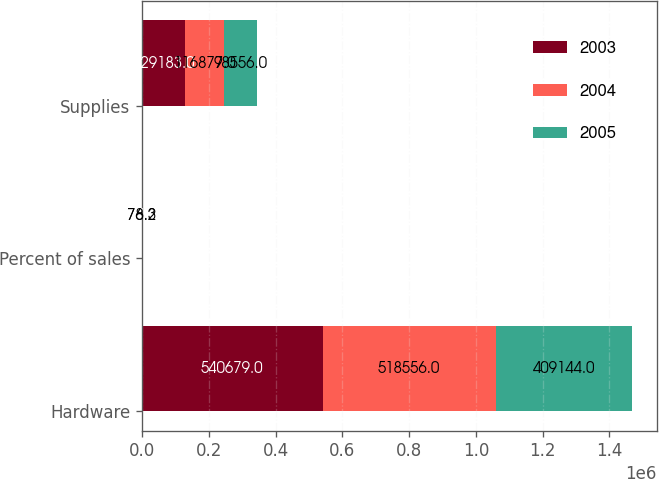<chart> <loc_0><loc_0><loc_500><loc_500><stacked_bar_chart><ecel><fcel>Hardware<fcel>Percent of sales<fcel>Supplies<nl><fcel>2003<fcel>540679<fcel>77<fcel>129183<nl><fcel>2004<fcel>518556<fcel>78.2<fcel>116877<nl><fcel>2005<fcel>409144<fcel>76.3<fcel>98556<nl></chart> 